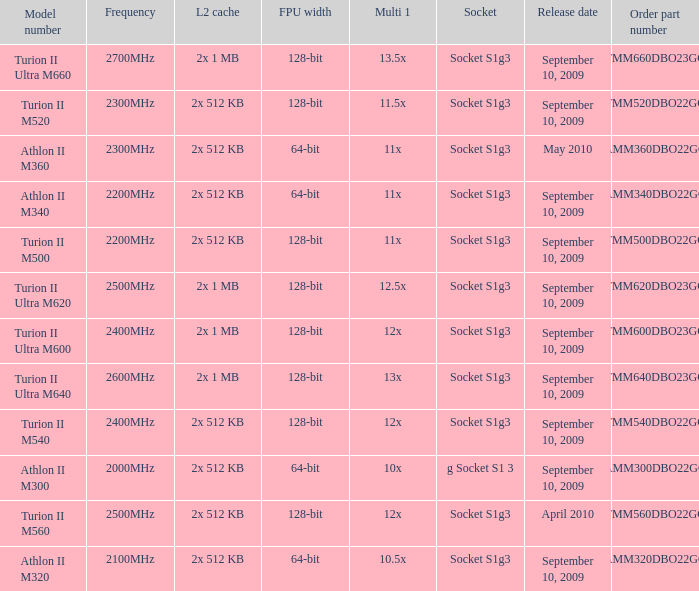What is the socket with an order part number of amm300dbo22gq and a September 10, 2009 release date? G socket s1 3. 